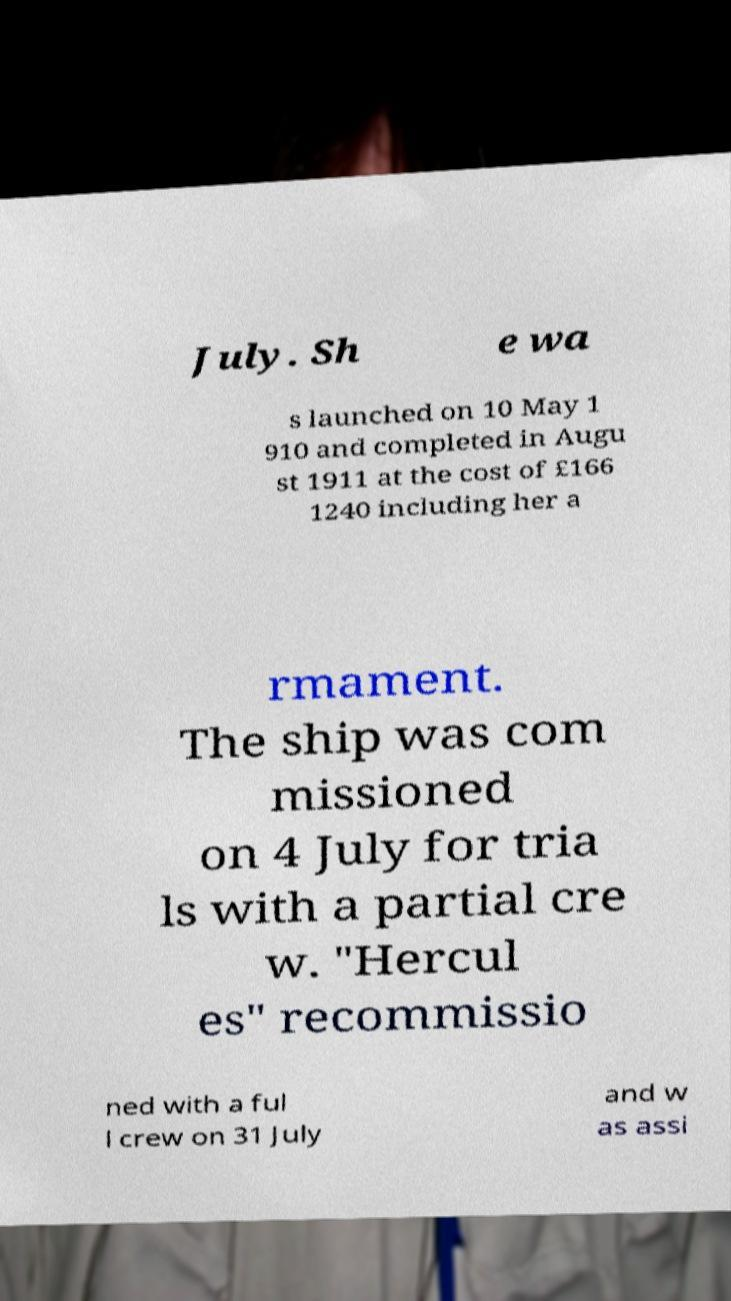There's text embedded in this image that I need extracted. Can you transcribe it verbatim? July. Sh e wa s launched on 10 May 1 910 and completed in Augu st 1911 at the cost of £166 1240 including her a rmament. The ship was com missioned on 4 July for tria ls with a partial cre w. "Hercul es" recommissio ned with a ful l crew on 31 July and w as assi 